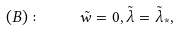<formula> <loc_0><loc_0><loc_500><loc_500>( B ) \colon \quad \tilde { w } = 0 , \tilde { \lambda } = \tilde { \lambda } _ { * } ,</formula> 